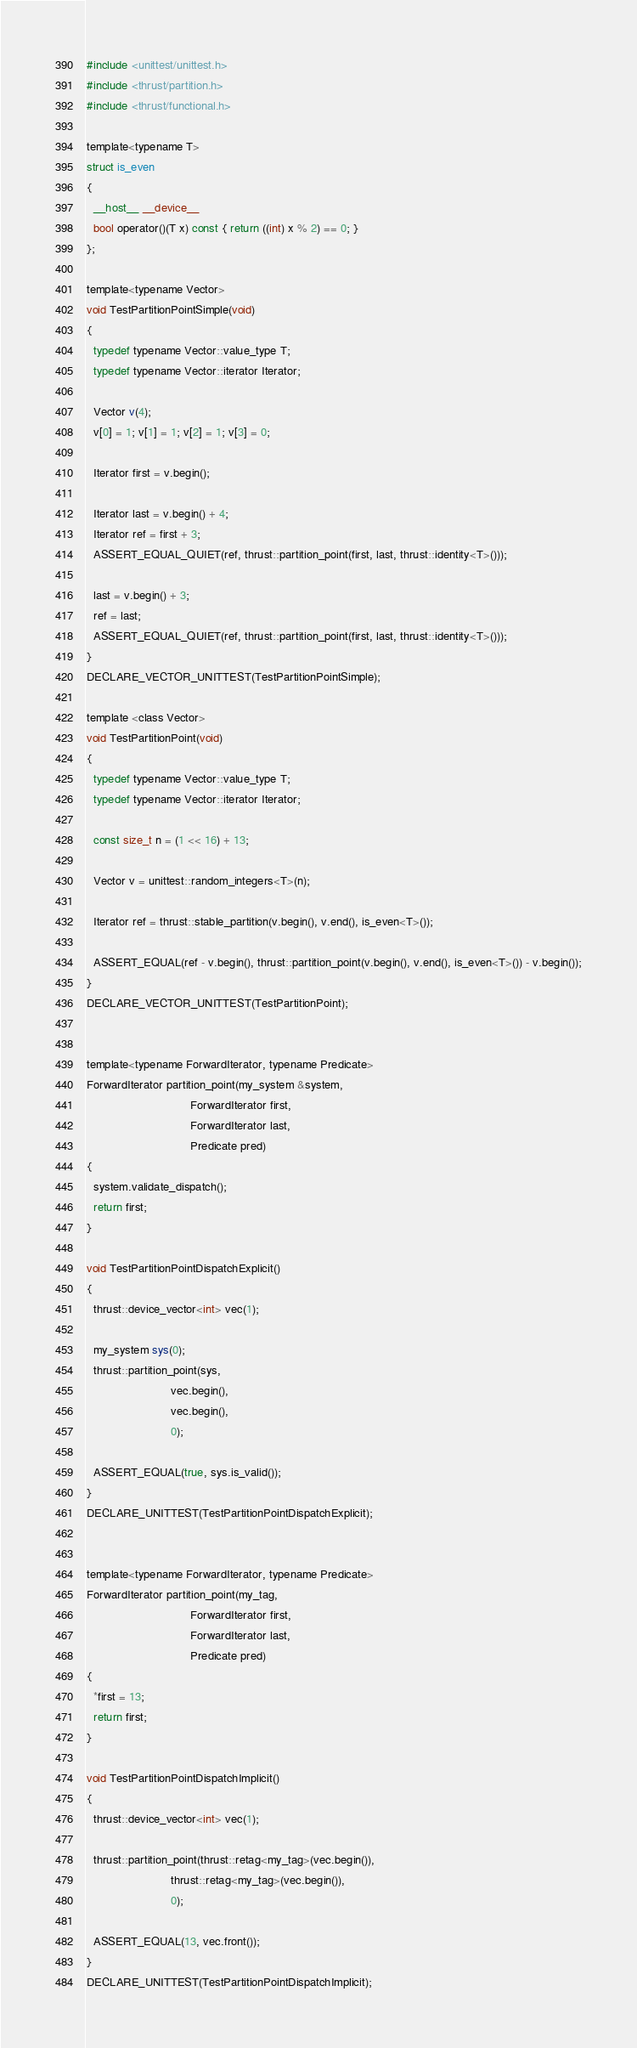Convert code to text. <code><loc_0><loc_0><loc_500><loc_500><_Cuda_>#include <unittest/unittest.h>
#include <thrust/partition.h>
#include <thrust/functional.h>

template<typename T>
struct is_even
{
  __host__ __device__
  bool operator()(T x) const { return ((int) x % 2) == 0; }
};

template<typename Vector>
void TestPartitionPointSimple(void)
{
  typedef typename Vector::value_type T;
  typedef typename Vector::iterator Iterator;

  Vector v(4);
  v[0] = 1; v[1] = 1; v[2] = 1; v[3] = 0;

  Iterator first = v.begin();

  Iterator last = v.begin() + 4;
  Iterator ref = first + 3;
  ASSERT_EQUAL_QUIET(ref, thrust::partition_point(first, last, thrust::identity<T>()));

  last = v.begin() + 3;
  ref = last;
  ASSERT_EQUAL_QUIET(ref, thrust::partition_point(first, last, thrust::identity<T>()));
}
DECLARE_VECTOR_UNITTEST(TestPartitionPointSimple);

template <class Vector>
void TestPartitionPoint(void)
{
  typedef typename Vector::value_type T;
  typedef typename Vector::iterator Iterator;

  const size_t n = (1 << 16) + 13;

  Vector v = unittest::random_integers<T>(n);

  Iterator ref = thrust::stable_partition(v.begin(), v.end(), is_even<T>());

  ASSERT_EQUAL(ref - v.begin(), thrust::partition_point(v.begin(), v.end(), is_even<T>()) - v.begin());
}
DECLARE_VECTOR_UNITTEST(TestPartitionPoint);


template<typename ForwardIterator, typename Predicate>
ForwardIterator partition_point(my_system &system, 
                                ForwardIterator first,
                                ForwardIterator last,
                                Predicate pred)
{
  system.validate_dispatch();
  return first;
}

void TestPartitionPointDispatchExplicit()
{
  thrust::device_vector<int> vec(1);

  my_system sys(0);
  thrust::partition_point(sys,
                          vec.begin(),
                          vec.begin(),
                          0);

  ASSERT_EQUAL(true, sys.is_valid());
}
DECLARE_UNITTEST(TestPartitionPointDispatchExplicit);


template<typename ForwardIterator, typename Predicate>
ForwardIterator partition_point(my_tag,
                                ForwardIterator first,
                                ForwardIterator last,
                                Predicate pred)
{
  *first = 13;
  return first;
}

void TestPartitionPointDispatchImplicit()
{
  thrust::device_vector<int> vec(1);

  thrust::partition_point(thrust::retag<my_tag>(vec.begin()),
                          thrust::retag<my_tag>(vec.begin()),
                          0);

  ASSERT_EQUAL(13, vec.front());
}
DECLARE_UNITTEST(TestPartitionPointDispatchImplicit);

</code> 